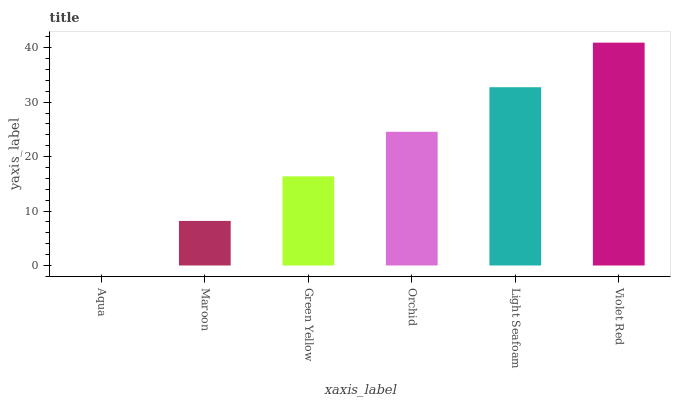Is Aqua the minimum?
Answer yes or no. Yes. Is Violet Red the maximum?
Answer yes or no. Yes. Is Maroon the minimum?
Answer yes or no. No. Is Maroon the maximum?
Answer yes or no. No. Is Maroon greater than Aqua?
Answer yes or no. Yes. Is Aqua less than Maroon?
Answer yes or no. Yes. Is Aqua greater than Maroon?
Answer yes or no. No. Is Maroon less than Aqua?
Answer yes or no. No. Is Orchid the high median?
Answer yes or no. Yes. Is Green Yellow the low median?
Answer yes or no. Yes. Is Light Seafoam the high median?
Answer yes or no. No. Is Violet Red the low median?
Answer yes or no. No. 